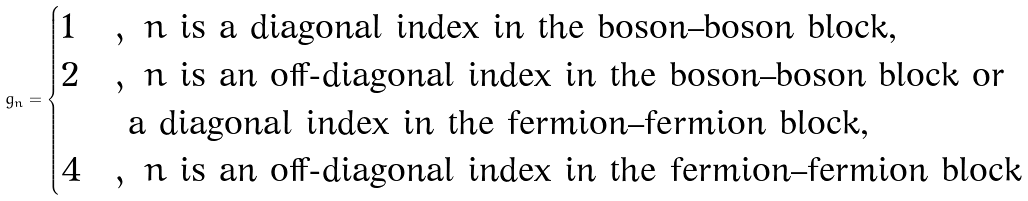<formula> <loc_0><loc_0><loc_500><loc_500>g _ { n } = \begin{cases} 1 & , \ n \text { is a diagonal index in the boson--boson block,} \\ 2 & , \ n \text { is an off-diagonal index in the boson--boson block or} \\ & \text { a diagonal index in the fermion--fermion block,} \\ 4 & , \ n \text { is an off-diagonal index in the fermion--fermion block} \end{cases}</formula> 